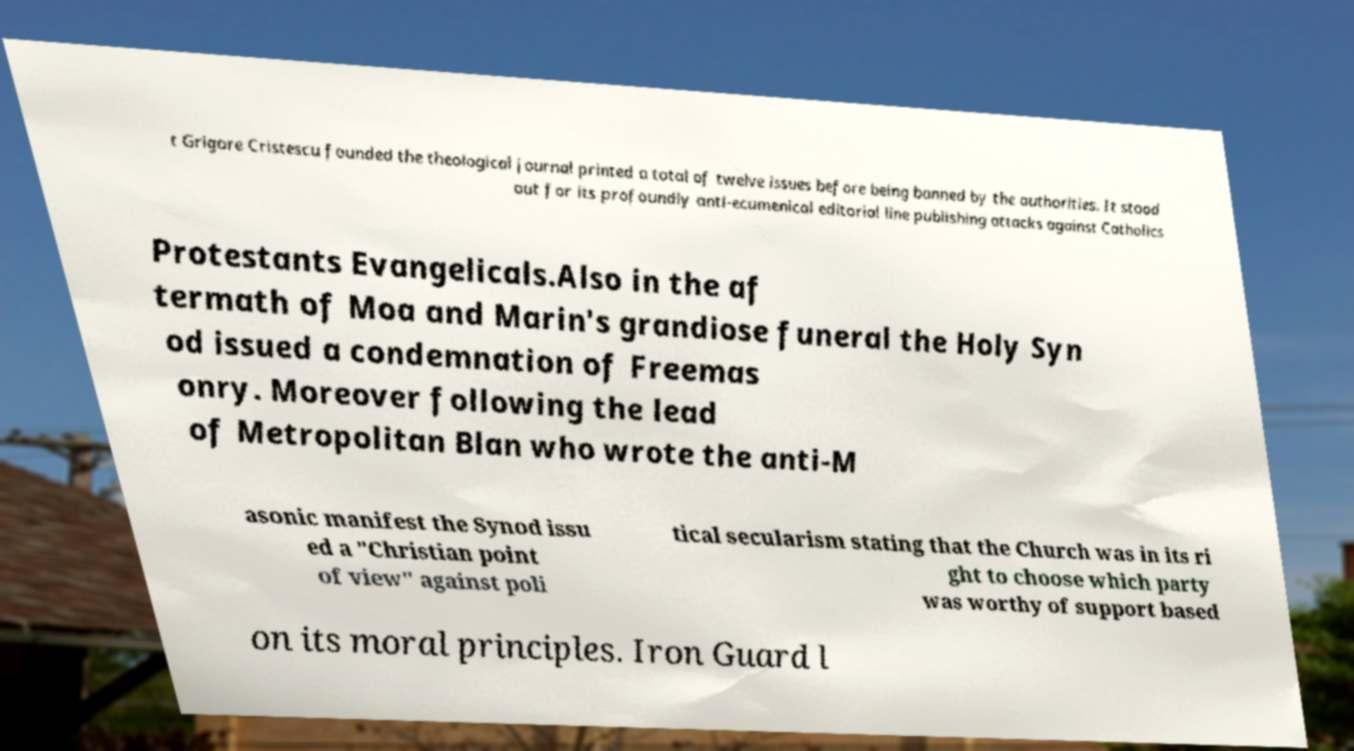Please read and relay the text visible in this image. What does it say? t Grigore Cristescu founded the theological journal printed a total of twelve issues before being banned by the authorities. It stood out for its profoundly anti-ecumenical editorial line publishing attacks against Catholics Protestants Evangelicals.Also in the af termath of Moa and Marin's grandiose funeral the Holy Syn od issued a condemnation of Freemas onry. Moreover following the lead of Metropolitan Blan who wrote the anti-M asonic manifest the Synod issu ed a "Christian point of view" against poli tical secularism stating that the Church was in its ri ght to choose which party was worthy of support based on its moral principles. Iron Guard l 